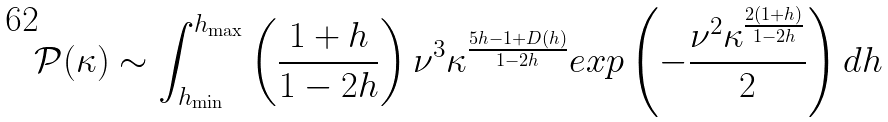Convert formula to latex. <formula><loc_0><loc_0><loc_500><loc_500>\mathcal { P } ( \kappa ) \sim \int _ { h _ { \min } } ^ { h _ { \max } } \left ( \frac { 1 + h } { 1 - 2 h } \right ) \nu ^ { 3 } \kappa ^ { \frac { 5 h - 1 + D ( h ) } { 1 - 2 h } } e x p \left ( - \frac { \nu ^ { 2 } \kappa ^ { \frac { 2 ( 1 + h ) } { 1 - 2 h } } } { 2 } \right ) d h</formula> 